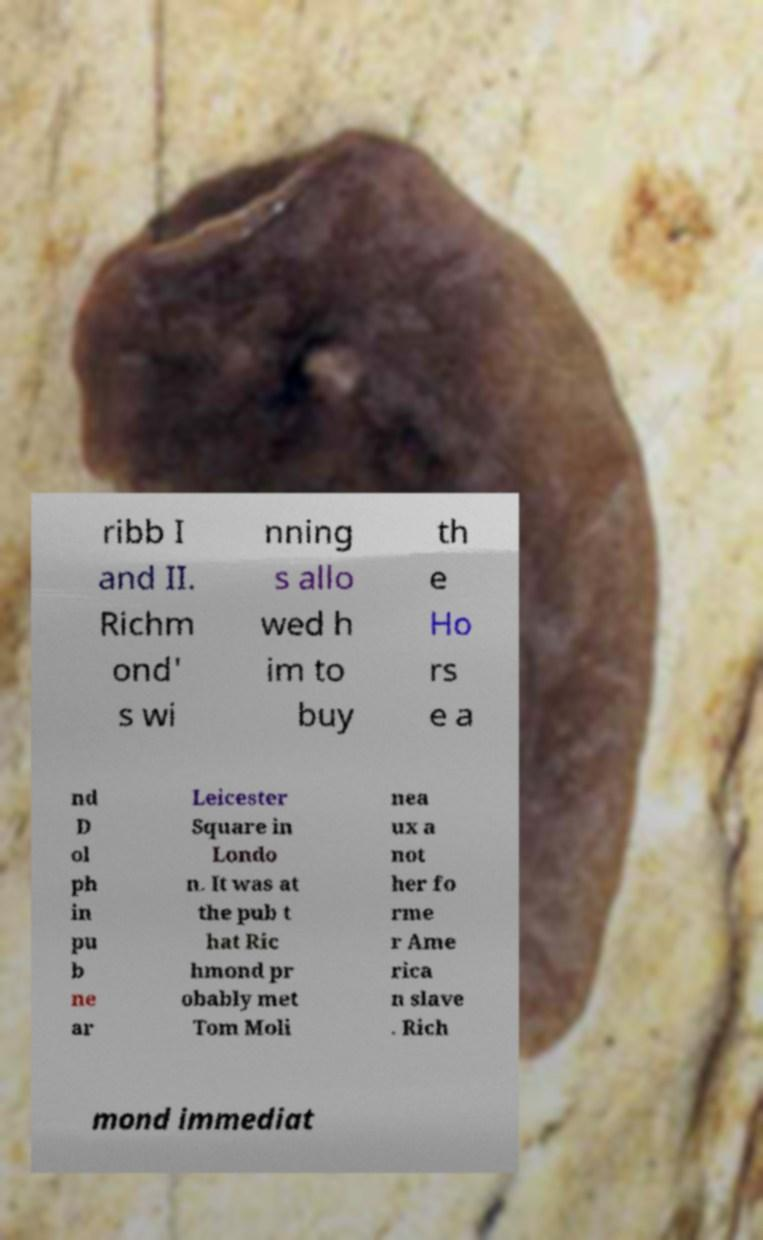Please read and relay the text visible in this image. What does it say? ribb I and II. Richm ond' s wi nning s allo wed h im to buy th e Ho rs e a nd D ol ph in pu b ne ar Leicester Square in Londo n. It was at the pub t hat Ric hmond pr obably met Tom Moli nea ux a not her fo rme r Ame rica n slave . Rich mond immediat 